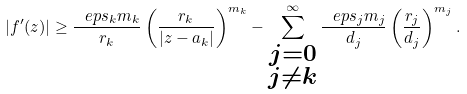<formula> <loc_0><loc_0><loc_500><loc_500>| f ^ { \prime } ( z ) | \geq \frac { \ e p s _ { k } m _ { k } } { r _ { k } } \left ( \frac { r _ { k } } { | z - a _ { k } | } \right ) ^ { m _ { k } } - \sum _ { \substack { j = 0 \\ j \neq k } } ^ { \infty } \frac { \ e p s _ { j } m _ { j } } { d _ { j } } \left ( \frac { r _ { j } } { d _ { j } } \right ) ^ { m _ { j } } .</formula> 